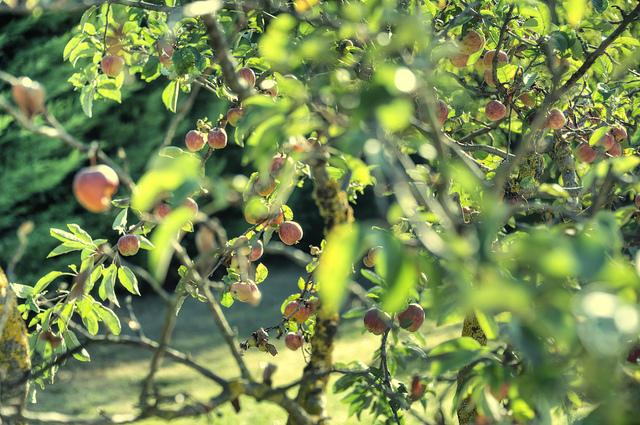What color apples are on the tree?
Short answer required. Red. What is the fruit shown?
Short answer required. Apple. What color are the leaves?
Short answer required. Green. Are these banana trees?
Give a very brief answer. No. What is in the fork of the tree?
Quick response, please. Fruit. What kind of tree are those?
Keep it brief. Peach. How many bananas are hanging from the tree?
Be succinct. 0. Is the fruit ripe?
Give a very brief answer. Yes. How many apples are there?
Write a very short answer. Lot. What kind of tree is this?
Write a very short answer. Peach. What color is this fruit when ripe?
Short answer required. Red. How many birds are depicted?
Be succinct. 0. What is the specific variety of peach tree shown?
Be succinct. Georgia. What is this large farm of orange trees called?
Give a very brief answer. Orchard. What season is this?
Short answer required. Spring. Are the fruits ripe?
Answer briefly. Yes. Is the tree alive?
Concise answer only. Yes. What color are the berries on the tree?
Short answer required. Red. Is the tree full of fruits?
Keep it brief. Yes. 